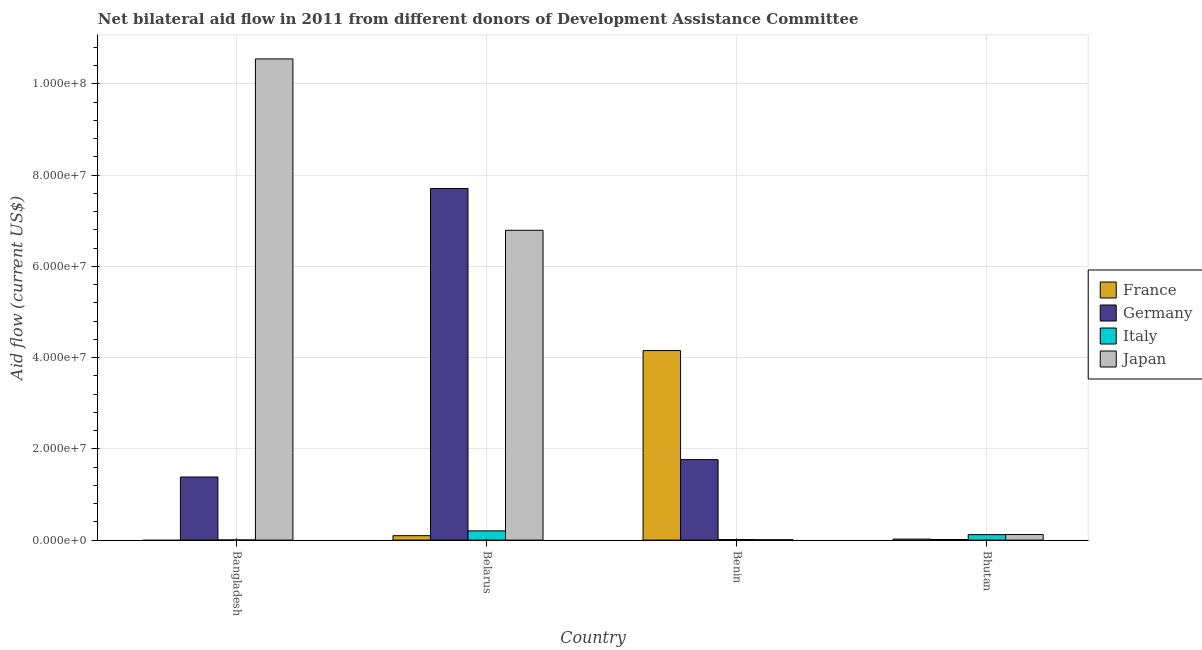How many groups of bars are there?
Offer a terse response. 4. Are the number of bars per tick equal to the number of legend labels?
Give a very brief answer. No. Are the number of bars on each tick of the X-axis equal?
Your response must be concise. No. What is the label of the 1st group of bars from the left?
Your answer should be very brief. Bangladesh. What is the amount of aid given by italy in Belarus?
Give a very brief answer. 2.02e+06. Across all countries, what is the maximum amount of aid given by japan?
Provide a succinct answer. 1.05e+08. Across all countries, what is the minimum amount of aid given by japan?
Provide a succinct answer. 8.00e+04. In which country was the amount of aid given by japan maximum?
Offer a terse response. Bangladesh. What is the total amount of aid given by italy in the graph?
Offer a terse response. 3.37e+06. What is the difference between the amount of aid given by italy in Bangladesh and that in Bhutan?
Your response must be concise. -1.17e+06. What is the difference between the amount of aid given by italy in Bangladesh and the amount of aid given by france in Belarus?
Keep it short and to the point. -9.40e+05. What is the average amount of aid given by italy per country?
Offer a terse response. 8.42e+05. What is the difference between the amount of aid given by france and amount of aid given by japan in Belarus?
Provide a short and direct response. -6.69e+07. What is the ratio of the amount of aid given by italy in Benin to that in Bhutan?
Give a very brief answer. 0.1. Is the difference between the amount of aid given by italy in Belarus and Benin greater than the difference between the amount of aid given by germany in Belarus and Benin?
Keep it short and to the point. No. What is the difference between the highest and the second highest amount of aid given by germany?
Offer a very short reply. 5.94e+07. What is the difference between the highest and the lowest amount of aid given by germany?
Provide a succinct answer. 7.69e+07. Is it the case that in every country, the sum of the amount of aid given by italy and amount of aid given by france is greater than the sum of amount of aid given by japan and amount of aid given by germany?
Provide a short and direct response. No. Are all the bars in the graph horizontal?
Keep it short and to the point. No. Are the values on the major ticks of Y-axis written in scientific E-notation?
Give a very brief answer. Yes. Where does the legend appear in the graph?
Your answer should be very brief. Center right. How many legend labels are there?
Your answer should be compact. 4. How are the legend labels stacked?
Ensure brevity in your answer.  Vertical. What is the title of the graph?
Make the answer very short. Net bilateral aid flow in 2011 from different donors of Development Assistance Committee. Does "Tracking ability" appear as one of the legend labels in the graph?
Provide a short and direct response. No. What is the label or title of the X-axis?
Keep it short and to the point. Country. What is the label or title of the Y-axis?
Keep it short and to the point. Aid flow (current US$). What is the Aid flow (current US$) of Germany in Bangladesh?
Ensure brevity in your answer.  1.38e+07. What is the Aid flow (current US$) in Italy in Bangladesh?
Provide a short and direct response. 3.00e+04. What is the Aid flow (current US$) of Japan in Bangladesh?
Your response must be concise. 1.05e+08. What is the Aid flow (current US$) in France in Belarus?
Offer a very short reply. 9.70e+05. What is the Aid flow (current US$) of Germany in Belarus?
Your answer should be very brief. 7.71e+07. What is the Aid flow (current US$) in Italy in Belarus?
Your answer should be very brief. 2.02e+06. What is the Aid flow (current US$) in Japan in Belarus?
Your response must be concise. 6.79e+07. What is the Aid flow (current US$) of France in Benin?
Make the answer very short. 4.15e+07. What is the Aid flow (current US$) of Germany in Benin?
Your answer should be very brief. 1.76e+07. What is the Aid flow (current US$) of Japan in Benin?
Provide a short and direct response. 8.00e+04. What is the Aid flow (current US$) of Germany in Bhutan?
Offer a terse response. 1.30e+05. What is the Aid flow (current US$) of Italy in Bhutan?
Provide a short and direct response. 1.20e+06. What is the Aid flow (current US$) of Japan in Bhutan?
Your response must be concise. 1.22e+06. Across all countries, what is the maximum Aid flow (current US$) in France?
Provide a short and direct response. 4.15e+07. Across all countries, what is the maximum Aid flow (current US$) of Germany?
Keep it short and to the point. 7.71e+07. Across all countries, what is the maximum Aid flow (current US$) in Italy?
Offer a very short reply. 2.02e+06. Across all countries, what is the maximum Aid flow (current US$) of Japan?
Provide a succinct answer. 1.05e+08. Across all countries, what is the minimum Aid flow (current US$) in France?
Your answer should be very brief. 0. Across all countries, what is the minimum Aid flow (current US$) in Japan?
Keep it short and to the point. 8.00e+04. What is the total Aid flow (current US$) in France in the graph?
Give a very brief answer. 4.27e+07. What is the total Aid flow (current US$) in Germany in the graph?
Your answer should be compact. 1.09e+08. What is the total Aid flow (current US$) of Italy in the graph?
Your answer should be very brief. 3.37e+06. What is the total Aid flow (current US$) in Japan in the graph?
Provide a short and direct response. 1.75e+08. What is the difference between the Aid flow (current US$) of Germany in Bangladesh and that in Belarus?
Make the answer very short. -6.32e+07. What is the difference between the Aid flow (current US$) in Italy in Bangladesh and that in Belarus?
Offer a terse response. -1.99e+06. What is the difference between the Aid flow (current US$) of Japan in Bangladesh and that in Belarus?
Your answer should be very brief. 3.76e+07. What is the difference between the Aid flow (current US$) in Germany in Bangladesh and that in Benin?
Your answer should be very brief. -3.81e+06. What is the difference between the Aid flow (current US$) of Japan in Bangladesh and that in Benin?
Offer a terse response. 1.05e+08. What is the difference between the Aid flow (current US$) in Germany in Bangladesh and that in Bhutan?
Your answer should be very brief. 1.37e+07. What is the difference between the Aid flow (current US$) of Italy in Bangladesh and that in Bhutan?
Give a very brief answer. -1.17e+06. What is the difference between the Aid flow (current US$) in Japan in Bangladesh and that in Bhutan?
Offer a very short reply. 1.04e+08. What is the difference between the Aid flow (current US$) of France in Belarus and that in Benin?
Provide a succinct answer. -4.06e+07. What is the difference between the Aid flow (current US$) in Germany in Belarus and that in Benin?
Provide a succinct answer. 5.94e+07. What is the difference between the Aid flow (current US$) of Italy in Belarus and that in Benin?
Offer a terse response. 1.90e+06. What is the difference between the Aid flow (current US$) in Japan in Belarus and that in Benin?
Your answer should be compact. 6.78e+07. What is the difference between the Aid flow (current US$) of France in Belarus and that in Bhutan?
Your answer should be very brief. 7.50e+05. What is the difference between the Aid flow (current US$) of Germany in Belarus and that in Bhutan?
Make the answer very short. 7.69e+07. What is the difference between the Aid flow (current US$) in Italy in Belarus and that in Bhutan?
Your answer should be compact. 8.20e+05. What is the difference between the Aid flow (current US$) of Japan in Belarus and that in Bhutan?
Offer a terse response. 6.67e+07. What is the difference between the Aid flow (current US$) in France in Benin and that in Bhutan?
Your answer should be compact. 4.13e+07. What is the difference between the Aid flow (current US$) of Germany in Benin and that in Bhutan?
Give a very brief answer. 1.75e+07. What is the difference between the Aid flow (current US$) of Italy in Benin and that in Bhutan?
Provide a short and direct response. -1.08e+06. What is the difference between the Aid flow (current US$) of Japan in Benin and that in Bhutan?
Your answer should be very brief. -1.14e+06. What is the difference between the Aid flow (current US$) of Germany in Bangladesh and the Aid flow (current US$) of Italy in Belarus?
Your answer should be very brief. 1.18e+07. What is the difference between the Aid flow (current US$) in Germany in Bangladesh and the Aid flow (current US$) in Japan in Belarus?
Provide a succinct answer. -5.41e+07. What is the difference between the Aid flow (current US$) in Italy in Bangladesh and the Aid flow (current US$) in Japan in Belarus?
Your answer should be very brief. -6.79e+07. What is the difference between the Aid flow (current US$) of Germany in Bangladesh and the Aid flow (current US$) of Italy in Benin?
Make the answer very short. 1.37e+07. What is the difference between the Aid flow (current US$) in Germany in Bangladesh and the Aid flow (current US$) in Japan in Benin?
Your answer should be compact. 1.38e+07. What is the difference between the Aid flow (current US$) in Italy in Bangladesh and the Aid flow (current US$) in Japan in Benin?
Your answer should be compact. -5.00e+04. What is the difference between the Aid flow (current US$) in Germany in Bangladesh and the Aid flow (current US$) in Italy in Bhutan?
Keep it short and to the point. 1.26e+07. What is the difference between the Aid flow (current US$) in Germany in Bangladesh and the Aid flow (current US$) in Japan in Bhutan?
Your answer should be compact. 1.26e+07. What is the difference between the Aid flow (current US$) of Italy in Bangladesh and the Aid flow (current US$) of Japan in Bhutan?
Make the answer very short. -1.19e+06. What is the difference between the Aid flow (current US$) of France in Belarus and the Aid flow (current US$) of Germany in Benin?
Offer a very short reply. -1.67e+07. What is the difference between the Aid flow (current US$) of France in Belarus and the Aid flow (current US$) of Italy in Benin?
Your answer should be very brief. 8.50e+05. What is the difference between the Aid flow (current US$) of France in Belarus and the Aid flow (current US$) of Japan in Benin?
Offer a very short reply. 8.90e+05. What is the difference between the Aid flow (current US$) of Germany in Belarus and the Aid flow (current US$) of Italy in Benin?
Provide a succinct answer. 7.69e+07. What is the difference between the Aid flow (current US$) in Germany in Belarus and the Aid flow (current US$) in Japan in Benin?
Keep it short and to the point. 7.70e+07. What is the difference between the Aid flow (current US$) in Italy in Belarus and the Aid flow (current US$) in Japan in Benin?
Give a very brief answer. 1.94e+06. What is the difference between the Aid flow (current US$) in France in Belarus and the Aid flow (current US$) in Germany in Bhutan?
Your answer should be very brief. 8.40e+05. What is the difference between the Aid flow (current US$) of Germany in Belarus and the Aid flow (current US$) of Italy in Bhutan?
Your answer should be very brief. 7.59e+07. What is the difference between the Aid flow (current US$) of Germany in Belarus and the Aid flow (current US$) of Japan in Bhutan?
Provide a short and direct response. 7.58e+07. What is the difference between the Aid flow (current US$) in Italy in Belarus and the Aid flow (current US$) in Japan in Bhutan?
Provide a succinct answer. 8.00e+05. What is the difference between the Aid flow (current US$) of France in Benin and the Aid flow (current US$) of Germany in Bhutan?
Your response must be concise. 4.14e+07. What is the difference between the Aid flow (current US$) in France in Benin and the Aid flow (current US$) in Italy in Bhutan?
Offer a terse response. 4.03e+07. What is the difference between the Aid flow (current US$) in France in Benin and the Aid flow (current US$) in Japan in Bhutan?
Your response must be concise. 4.03e+07. What is the difference between the Aid flow (current US$) in Germany in Benin and the Aid flow (current US$) in Italy in Bhutan?
Keep it short and to the point. 1.64e+07. What is the difference between the Aid flow (current US$) of Germany in Benin and the Aid flow (current US$) of Japan in Bhutan?
Offer a very short reply. 1.64e+07. What is the difference between the Aid flow (current US$) of Italy in Benin and the Aid flow (current US$) of Japan in Bhutan?
Make the answer very short. -1.10e+06. What is the average Aid flow (current US$) in France per country?
Provide a short and direct response. 1.07e+07. What is the average Aid flow (current US$) in Germany per country?
Give a very brief answer. 2.72e+07. What is the average Aid flow (current US$) of Italy per country?
Make the answer very short. 8.42e+05. What is the average Aid flow (current US$) in Japan per country?
Ensure brevity in your answer.  4.37e+07. What is the difference between the Aid flow (current US$) in Germany and Aid flow (current US$) in Italy in Bangladesh?
Ensure brevity in your answer.  1.38e+07. What is the difference between the Aid flow (current US$) in Germany and Aid flow (current US$) in Japan in Bangladesh?
Make the answer very short. -9.16e+07. What is the difference between the Aid flow (current US$) of Italy and Aid flow (current US$) of Japan in Bangladesh?
Keep it short and to the point. -1.05e+08. What is the difference between the Aid flow (current US$) in France and Aid flow (current US$) in Germany in Belarus?
Ensure brevity in your answer.  -7.61e+07. What is the difference between the Aid flow (current US$) in France and Aid flow (current US$) in Italy in Belarus?
Your answer should be compact. -1.05e+06. What is the difference between the Aid flow (current US$) of France and Aid flow (current US$) of Japan in Belarus?
Ensure brevity in your answer.  -6.69e+07. What is the difference between the Aid flow (current US$) in Germany and Aid flow (current US$) in Italy in Belarus?
Your answer should be very brief. 7.50e+07. What is the difference between the Aid flow (current US$) of Germany and Aid flow (current US$) of Japan in Belarus?
Ensure brevity in your answer.  9.15e+06. What is the difference between the Aid flow (current US$) in Italy and Aid flow (current US$) in Japan in Belarus?
Make the answer very short. -6.59e+07. What is the difference between the Aid flow (current US$) in France and Aid flow (current US$) in Germany in Benin?
Keep it short and to the point. 2.39e+07. What is the difference between the Aid flow (current US$) in France and Aid flow (current US$) in Italy in Benin?
Your answer should be compact. 4.14e+07. What is the difference between the Aid flow (current US$) in France and Aid flow (current US$) in Japan in Benin?
Your response must be concise. 4.15e+07. What is the difference between the Aid flow (current US$) of Germany and Aid flow (current US$) of Italy in Benin?
Keep it short and to the point. 1.75e+07. What is the difference between the Aid flow (current US$) in Germany and Aid flow (current US$) in Japan in Benin?
Your answer should be compact. 1.76e+07. What is the difference between the Aid flow (current US$) in France and Aid flow (current US$) in Italy in Bhutan?
Give a very brief answer. -9.80e+05. What is the difference between the Aid flow (current US$) in France and Aid flow (current US$) in Japan in Bhutan?
Your answer should be compact. -1.00e+06. What is the difference between the Aid flow (current US$) of Germany and Aid flow (current US$) of Italy in Bhutan?
Offer a very short reply. -1.07e+06. What is the difference between the Aid flow (current US$) in Germany and Aid flow (current US$) in Japan in Bhutan?
Your answer should be compact. -1.09e+06. What is the ratio of the Aid flow (current US$) in Germany in Bangladesh to that in Belarus?
Your answer should be very brief. 0.18. What is the ratio of the Aid flow (current US$) of Italy in Bangladesh to that in Belarus?
Your response must be concise. 0.01. What is the ratio of the Aid flow (current US$) in Japan in Bangladesh to that in Belarus?
Offer a very short reply. 1.55. What is the ratio of the Aid flow (current US$) in Germany in Bangladesh to that in Benin?
Your response must be concise. 0.78. What is the ratio of the Aid flow (current US$) in Japan in Bangladesh to that in Benin?
Give a very brief answer. 1318.38. What is the ratio of the Aid flow (current US$) in Germany in Bangladesh to that in Bhutan?
Give a very brief answer. 106.38. What is the ratio of the Aid flow (current US$) of Italy in Bangladesh to that in Bhutan?
Provide a succinct answer. 0.03. What is the ratio of the Aid flow (current US$) in Japan in Bangladesh to that in Bhutan?
Your response must be concise. 86.45. What is the ratio of the Aid flow (current US$) in France in Belarus to that in Benin?
Offer a very short reply. 0.02. What is the ratio of the Aid flow (current US$) in Germany in Belarus to that in Benin?
Give a very brief answer. 4.37. What is the ratio of the Aid flow (current US$) of Italy in Belarus to that in Benin?
Offer a very short reply. 16.83. What is the ratio of the Aid flow (current US$) of Japan in Belarus to that in Benin?
Offer a very short reply. 848.88. What is the ratio of the Aid flow (current US$) in France in Belarus to that in Bhutan?
Offer a very short reply. 4.41. What is the ratio of the Aid flow (current US$) in Germany in Belarus to that in Bhutan?
Offer a very short reply. 592.77. What is the ratio of the Aid flow (current US$) in Italy in Belarus to that in Bhutan?
Your answer should be very brief. 1.68. What is the ratio of the Aid flow (current US$) of Japan in Belarus to that in Bhutan?
Your answer should be compact. 55.66. What is the ratio of the Aid flow (current US$) in France in Benin to that in Bhutan?
Make the answer very short. 188.82. What is the ratio of the Aid flow (current US$) in Germany in Benin to that in Bhutan?
Give a very brief answer. 135.69. What is the ratio of the Aid flow (current US$) in Italy in Benin to that in Bhutan?
Your answer should be very brief. 0.1. What is the ratio of the Aid flow (current US$) in Japan in Benin to that in Bhutan?
Make the answer very short. 0.07. What is the difference between the highest and the second highest Aid flow (current US$) in France?
Ensure brevity in your answer.  4.06e+07. What is the difference between the highest and the second highest Aid flow (current US$) of Germany?
Offer a terse response. 5.94e+07. What is the difference between the highest and the second highest Aid flow (current US$) of Italy?
Ensure brevity in your answer.  8.20e+05. What is the difference between the highest and the second highest Aid flow (current US$) of Japan?
Your answer should be compact. 3.76e+07. What is the difference between the highest and the lowest Aid flow (current US$) in France?
Ensure brevity in your answer.  4.15e+07. What is the difference between the highest and the lowest Aid flow (current US$) of Germany?
Offer a terse response. 7.69e+07. What is the difference between the highest and the lowest Aid flow (current US$) of Italy?
Your answer should be very brief. 1.99e+06. What is the difference between the highest and the lowest Aid flow (current US$) in Japan?
Offer a terse response. 1.05e+08. 